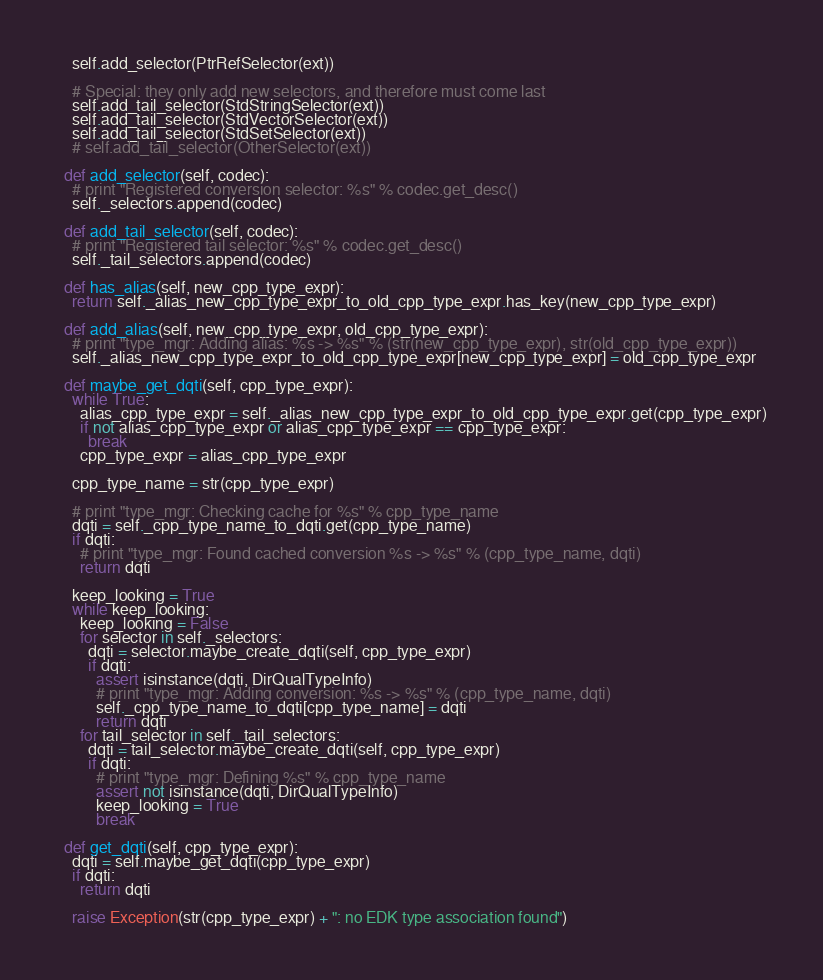<code> <loc_0><loc_0><loc_500><loc_500><_Python_>    self.add_selector(PtrRefSelector(ext))

    # Special: they only add new selectors, and therefore must come last
    self.add_tail_selector(StdStringSelector(ext))
    self.add_tail_selector(StdVectorSelector(ext))
    self.add_tail_selector(StdSetSelector(ext))
    # self.add_tail_selector(OtherSelector(ext))

  def add_selector(self, codec):
    # print "Registered conversion selector: %s" % codec.get_desc()
    self._selectors.append(codec)

  def add_tail_selector(self, codec):
    # print "Registered tail selector: %s" % codec.get_desc()
    self._tail_selectors.append(codec)

  def has_alias(self, new_cpp_type_expr):
    return self._alias_new_cpp_type_expr_to_old_cpp_type_expr.has_key(new_cpp_type_expr)

  def add_alias(self, new_cpp_type_expr, old_cpp_type_expr):
    # print "type_mgr: Adding alias: %s -> %s" % (str(new_cpp_type_expr), str(old_cpp_type_expr))
    self._alias_new_cpp_type_expr_to_old_cpp_type_expr[new_cpp_type_expr] = old_cpp_type_expr

  def maybe_get_dqti(self, cpp_type_expr):
    while True:
      alias_cpp_type_expr = self._alias_new_cpp_type_expr_to_old_cpp_type_expr.get(cpp_type_expr)
      if not alias_cpp_type_expr or alias_cpp_type_expr == cpp_type_expr:
        break
      cpp_type_expr = alias_cpp_type_expr

    cpp_type_name = str(cpp_type_expr)

    # print "type_mgr: Checking cache for %s" % cpp_type_name
    dqti = self._cpp_type_name_to_dqti.get(cpp_type_name)
    if dqti:
      # print "type_mgr: Found cached conversion %s -> %s" % (cpp_type_name, dqti)
      return dqti

    keep_looking = True
    while keep_looking:
      keep_looking = False
      for selector in self._selectors:
        dqti = selector.maybe_create_dqti(self, cpp_type_expr)
        if dqti:
          assert isinstance(dqti, DirQualTypeInfo)
          # print "type_mgr: Adding conversion: %s -> %s" % (cpp_type_name, dqti)
          self._cpp_type_name_to_dqti[cpp_type_name] = dqti
          return dqti
      for tail_selector in self._tail_selectors:
        dqti = tail_selector.maybe_create_dqti(self, cpp_type_expr)
        if dqti:
          # print "type_mgr: Defining %s" % cpp_type_name
          assert not isinstance(dqti, DirQualTypeInfo)
          keep_looking = True
          break

  def get_dqti(self, cpp_type_expr):
    dqti = self.maybe_get_dqti(cpp_type_expr)
    if dqti:
      return dqti

    raise Exception(str(cpp_type_expr) + ": no EDK type association found")
</code> 